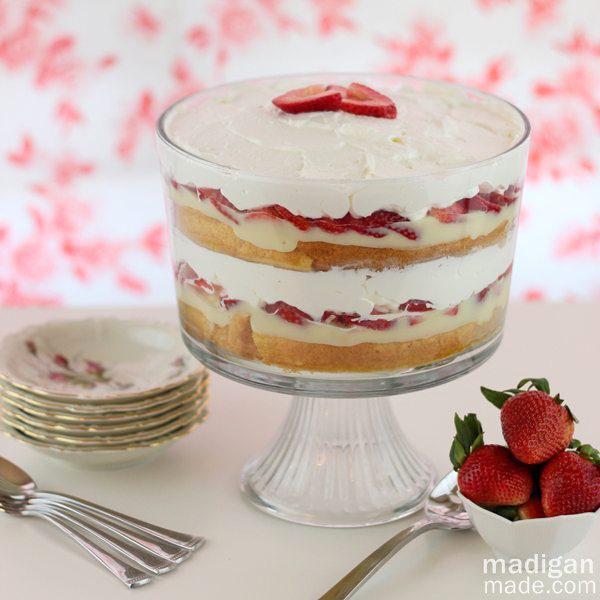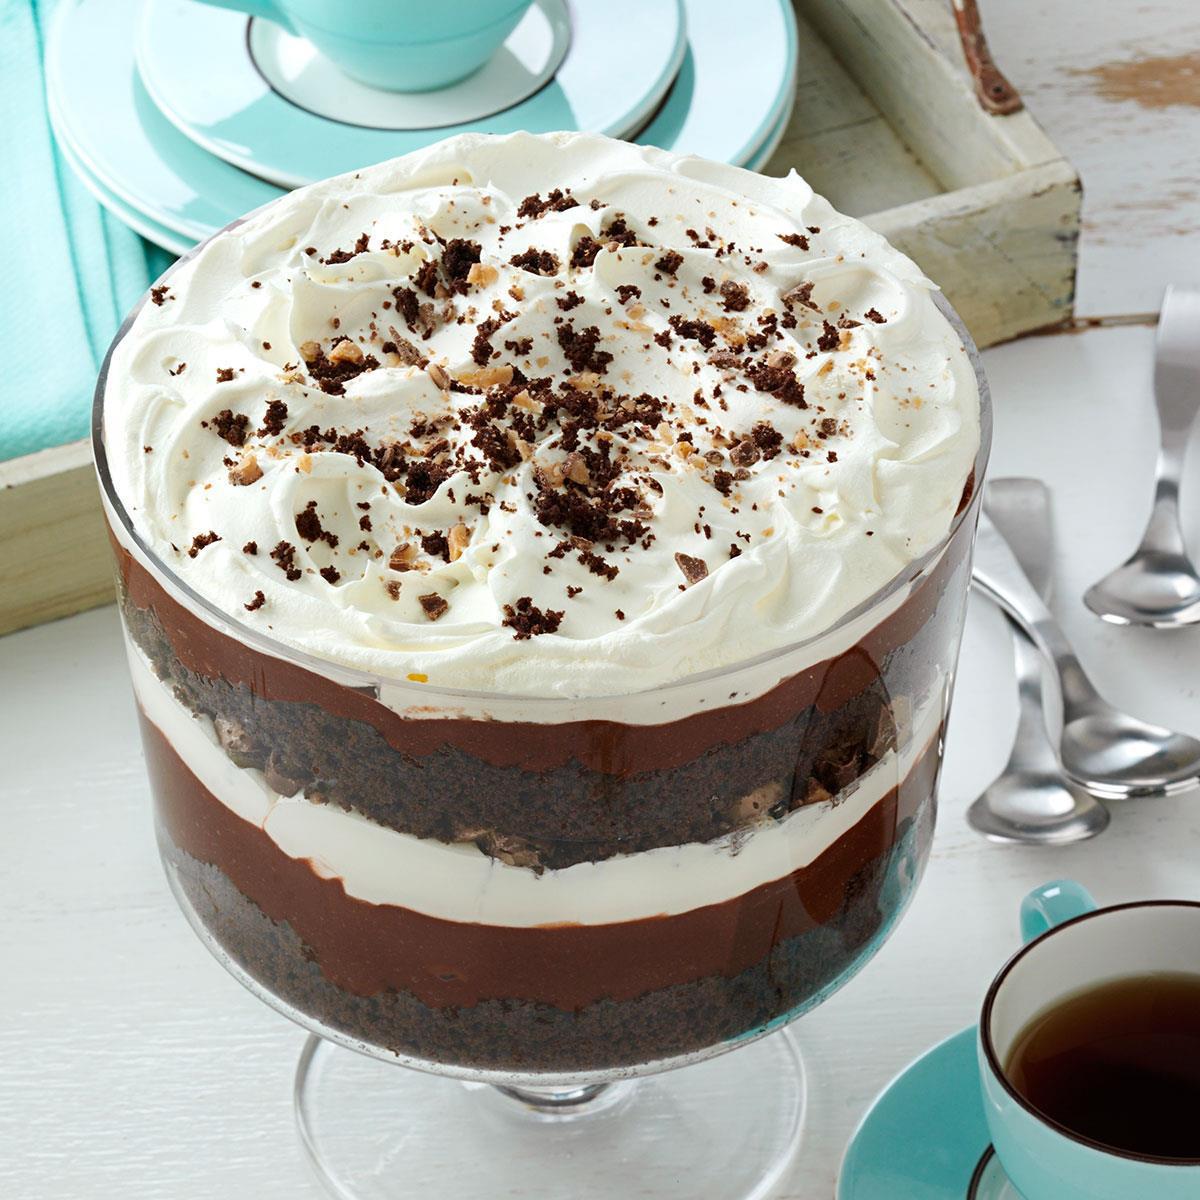The first image is the image on the left, the second image is the image on the right. For the images displayed, is the sentence "An image shows a layered dessert in a footed glass, with a topping that includes sliced strawberries." factually correct? Answer yes or no. Yes. The first image is the image on the left, the second image is the image on the right. Analyze the images presented: Is the assertion "The fancy dessert in one image is garnished with chocolate, while the other image shows dessert garnished with sliced fruit." valid? Answer yes or no. Yes. 